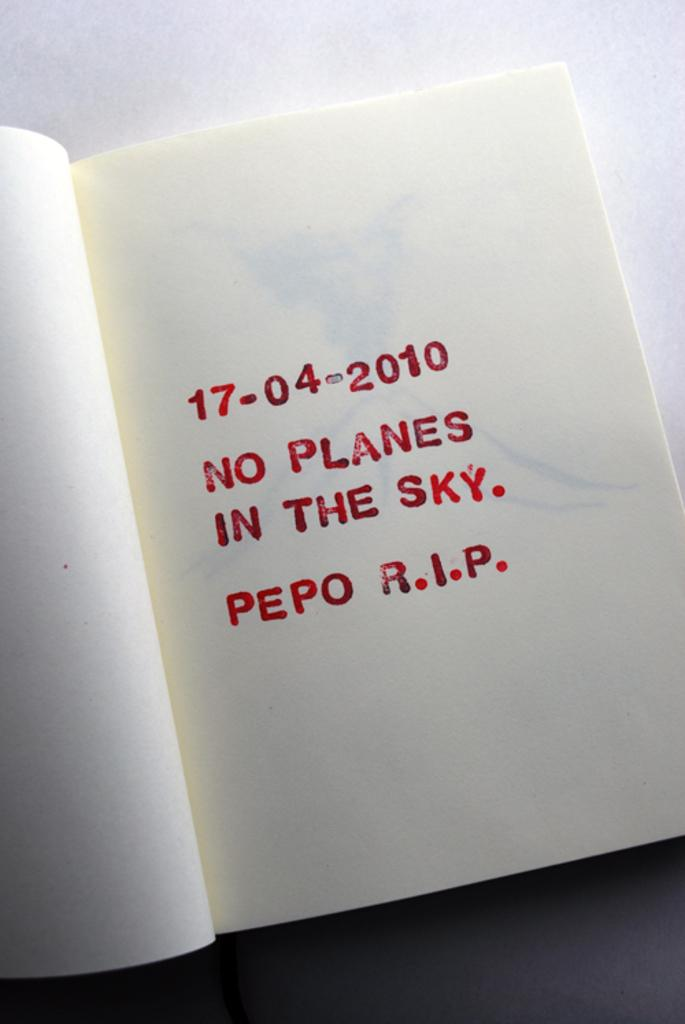Provide a one-sentence caption for the provided image. A book is open to a page with the date 17-04-2010. 